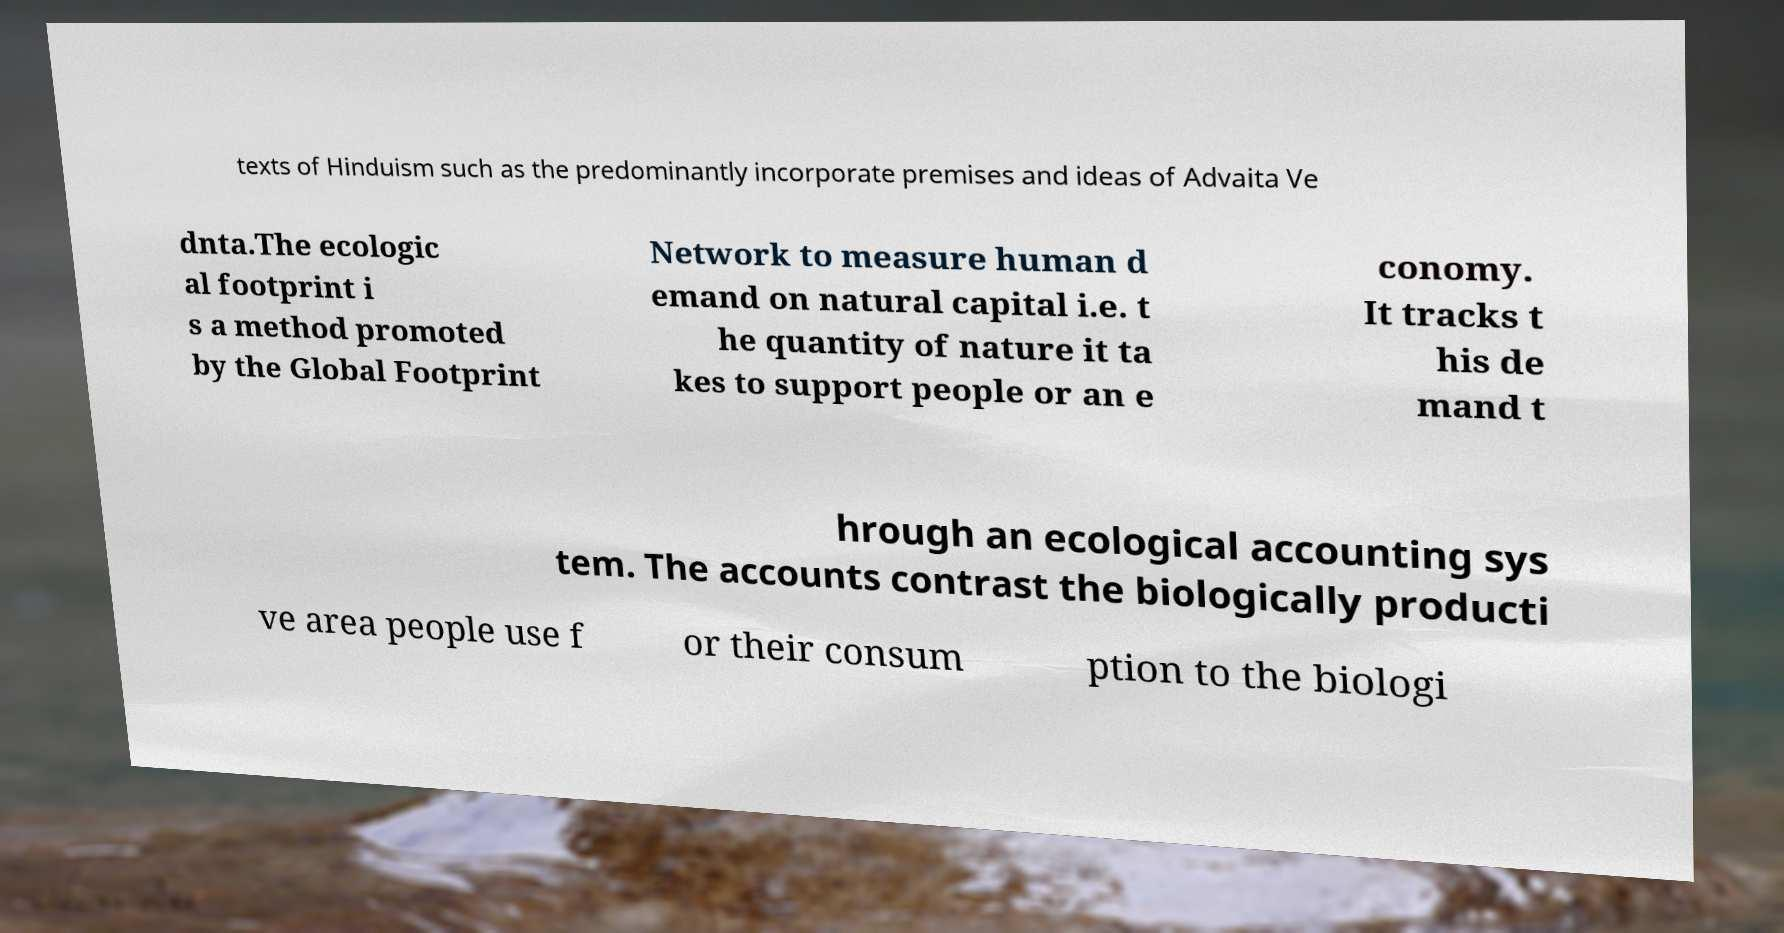Please read and relay the text visible in this image. What does it say? texts of Hinduism such as the predominantly incorporate premises and ideas of Advaita Ve dnta.The ecologic al footprint i s a method promoted by the Global Footprint Network to measure human d emand on natural capital i.e. t he quantity of nature it ta kes to support people or an e conomy. It tracks t his de mand t hrough an ecological accounting sys tem. The accounts contrast the biologically producti ve area people use f or their consum ption to the biologi 